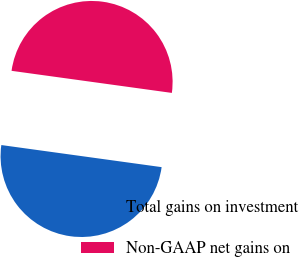<chart> <loc_0><loc_0><loc_500><loc_500><pie_chart><fcel>Total gains on investment<fcel>Non-GAAP net gains on<nl><fcel>50.0%<fcel>50.0%<nl></chart> 